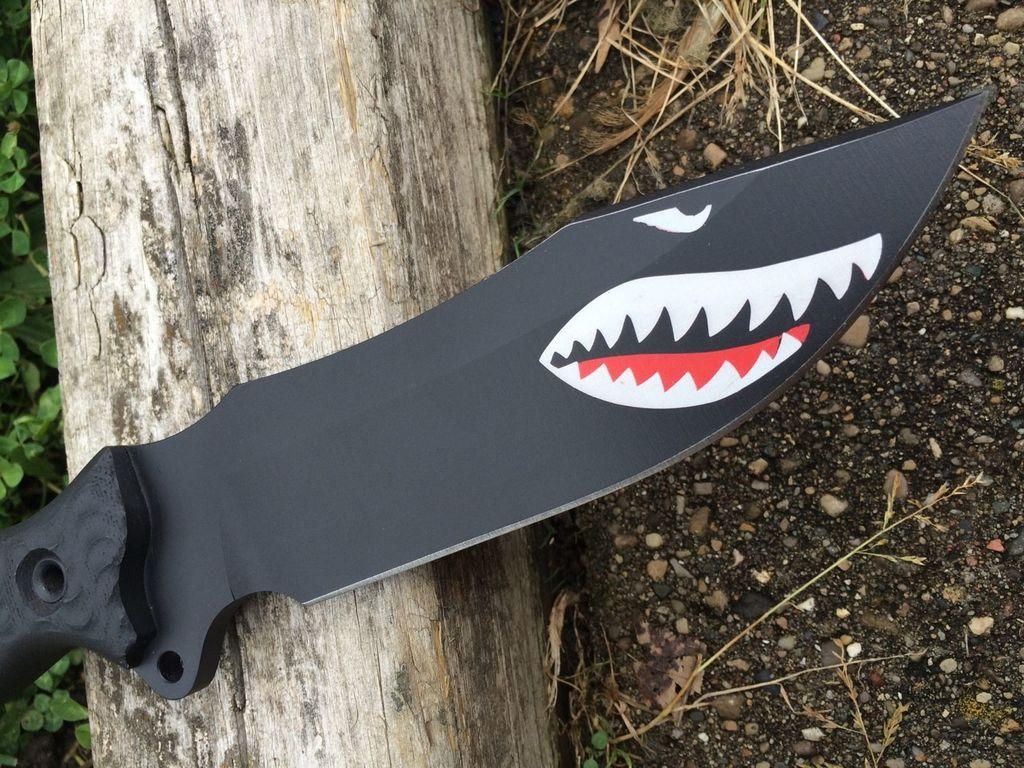What object can be seen in the image that is typically used for cutting? There is a knife in the image. What is the wooden object in the image? There is a wooden log in the image. What type of vegetation is present in the image? There are plants and grass in the image. What material is visible in the image that is often found in gardens or landscapes? There is soil in the image. What letters can be seen on the wooden log in the image? There are no letters visible on the wooden log in the image. How many ladybugs are present on the plants in the image? There are no ladybugs present in the image; only plants, grass, and soil are visible. 